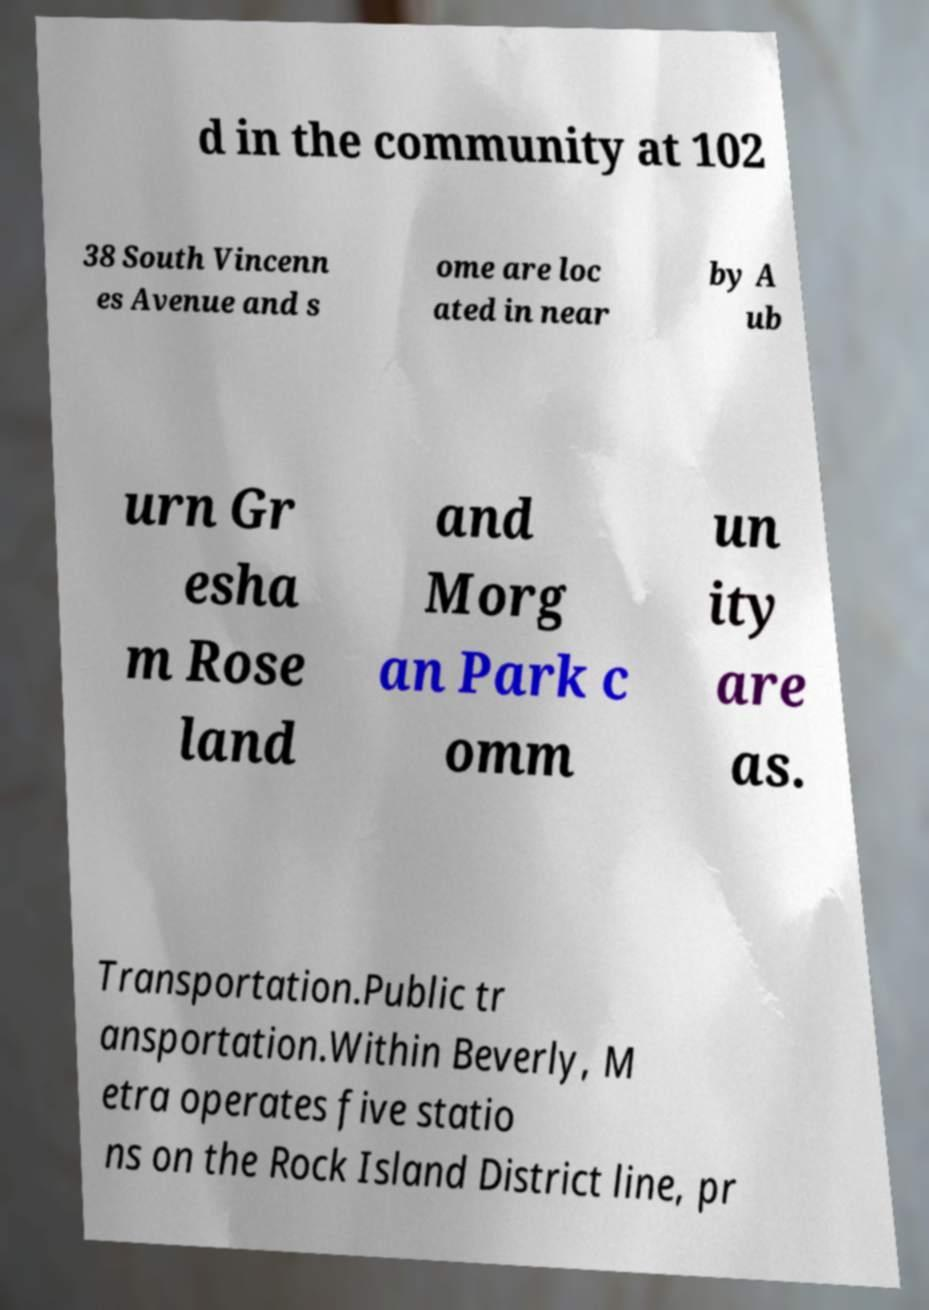There's text embedded in this image that I need extracted. Can you transcribe it verbatim? d in the community at 102 38 South Vincenn es Avenue and s ome are loc ated in near by A ub urn Gr esha m Rose land and Morg an Park c omm un ity are as. Transportation.Public tr ansportation.Within Beverly, M etra operates five statio ns on the Rock Island District line, pr 